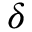<formula> <loc_0><loc_0><loc_500><loc_500>\delta</formula> 